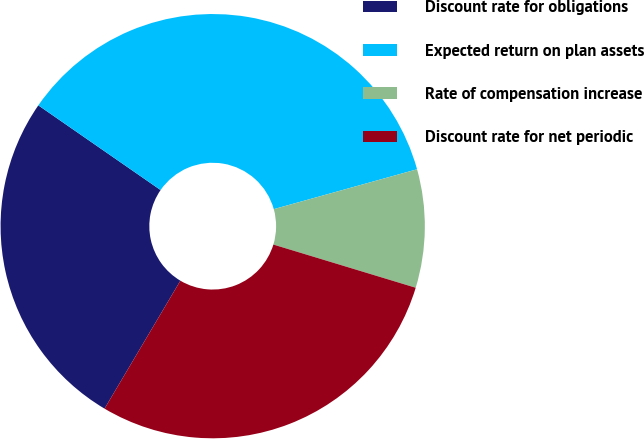Convert chart. <chart><loc_0><loc_0><loc_500><loc_500><pie_chart><fcel>Discount rate for obligations<fcel>Expected return on plan assets<fcel>Rate of compensation increase<fcel>Discount rate for net periodic<nl><fcel>26.13%<fcel>36.04%<fcel>9.01%<fcel>28.83%<nl></chart> 